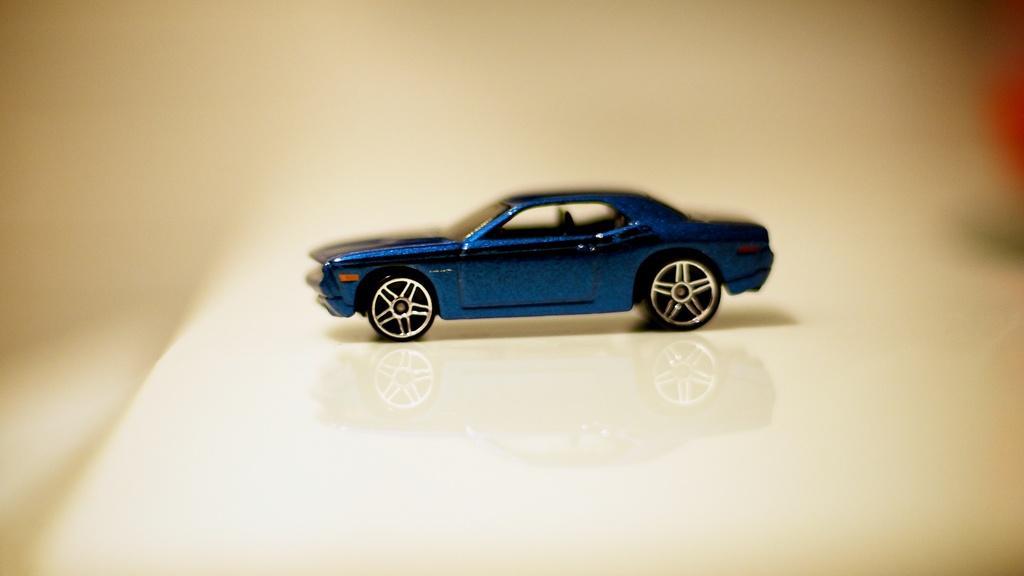How would you summarize this image in a sentence or two? In this image I can see a blue car and it is reflecting on the floor. And the background is blurry 